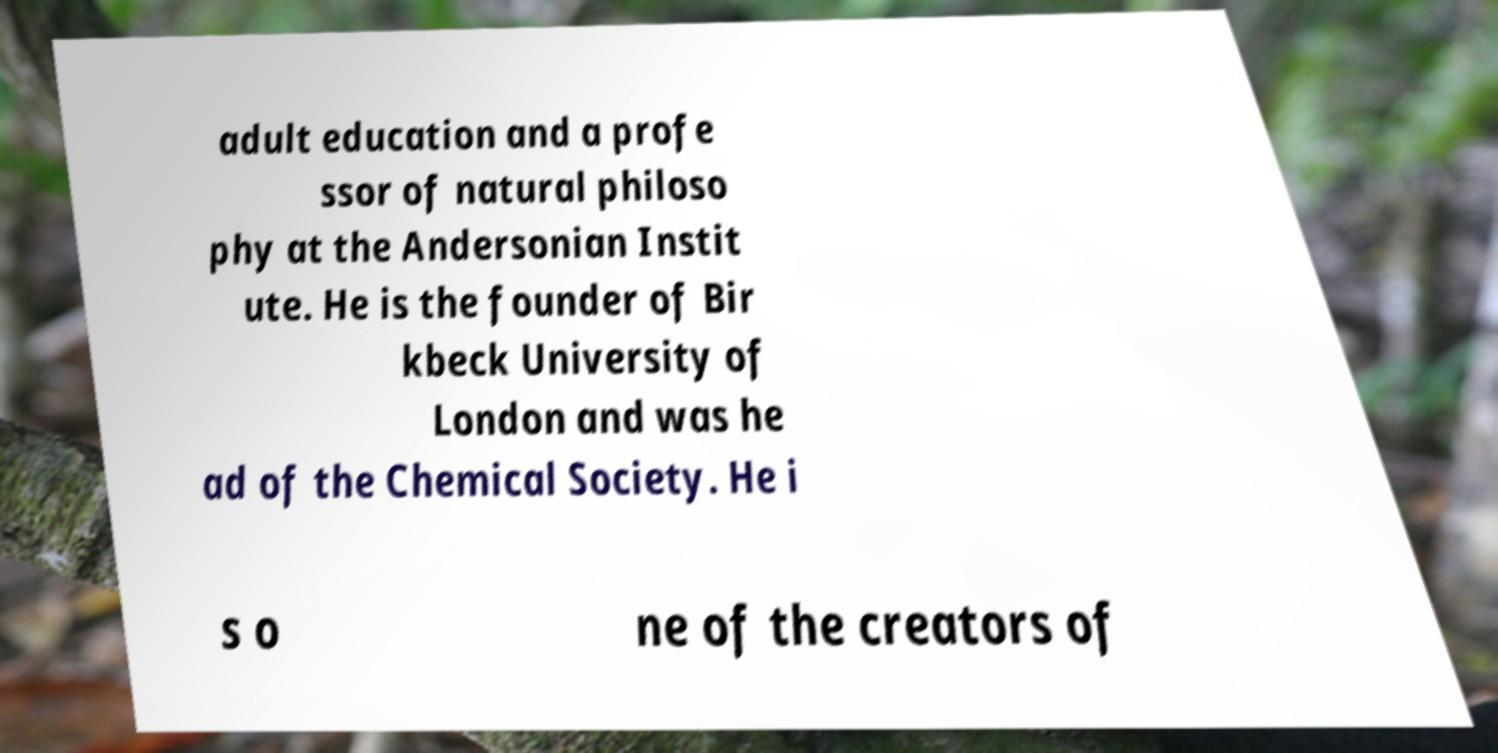There's text embedded in this image that I need extracted. Can you transcribe it verbatim? adult education and a profe ssor of natural philoso phy at the Andersonian Instit ute. He is the founder of Bir kbeck University of London and was he ad of the Chemical Society. He i s o ne of the creators of 